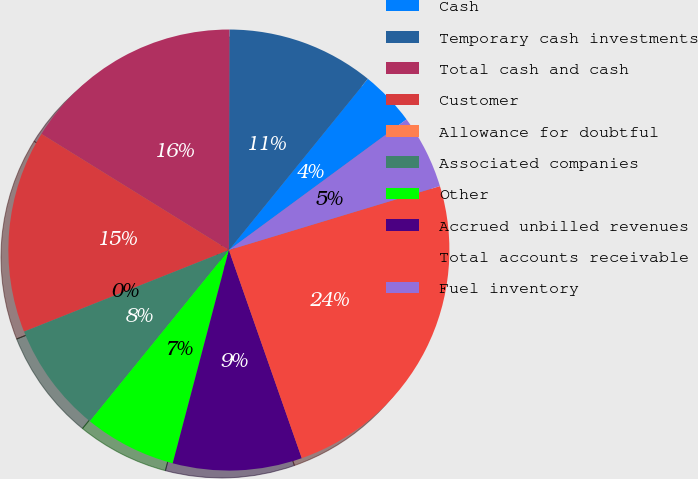Convert chart to OTSL. <chart><loc_0><loc_0><loc_500><loc_500><pie_chart><fcel>Cash<fcel>Temporary cash investments<fcel>Total cash and cash<fcel>Customer<fcel>Allowance for doubtful<fcel>Associated companies<fcel>Other<fcel>Accrued unbilled revenues<fcel>Total accounts receivable<fcel>Fuel inventory<nl><fcel>4.06%<fcel>10.81%<fcel>16.21%<fcel>14.86%<fcel>0.0%<fcel>8.11%<fcel>6.76%<fcel>9.46%<fcel>24.32%<fcel>5.41%<nl></chart> 